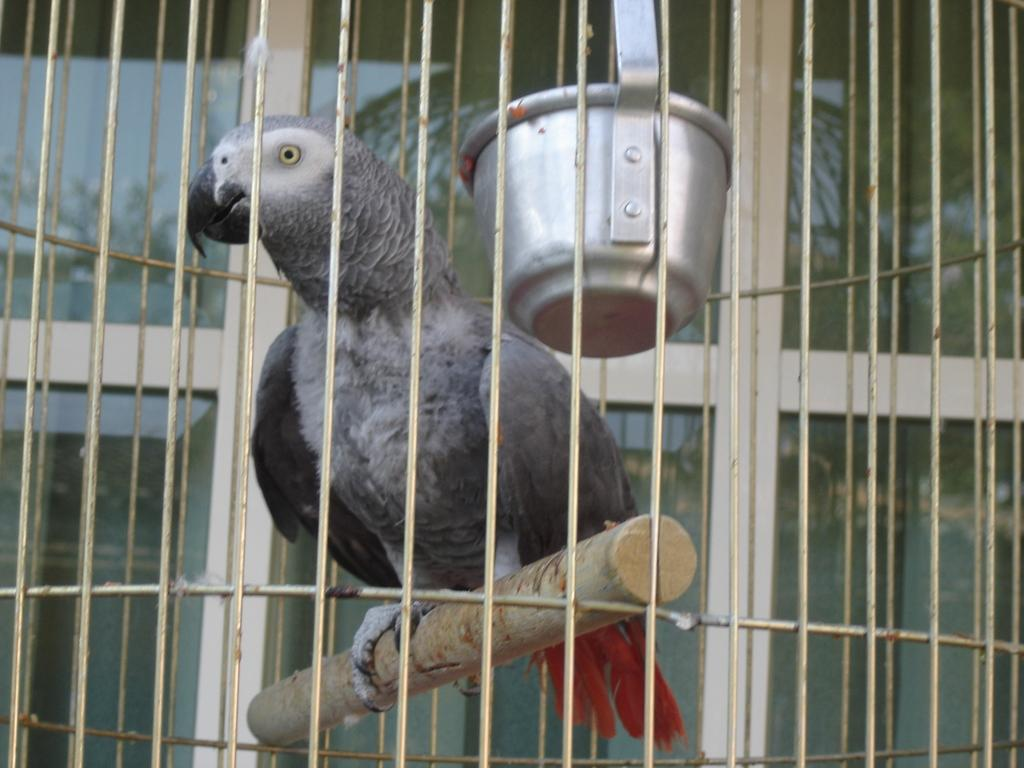What type of animal can be seen in the image? There is a bird in the image. What is the bird contained within in the image? There is an object in a cage in the image, which may contain the bird. How many matches are in the cage with the bird in the image? There are no matches present in the image; it only features a bird and an object in a cage. What scientific experiment is being conducted with the bird in the image? There is no indication of a scientific experiment being conducted in the image; it simply shows a bird in a cage. 